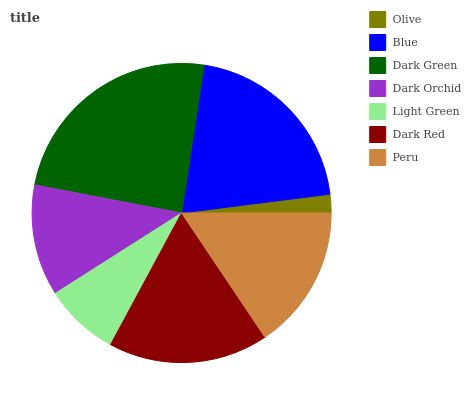Is Olive the minimum?
Answer yes or no. Yes. Is Dark Green the maximum?
Answer yes or no. Yes. Is Blue the minimum?
Answer yes or no. No. Is Blue the maximum?
Answer yes or no. No. Is Blue greater than Olive?
Answer yes or no. Yes. Is Olive less than Blue?
Answer yes or no. Yes. Is Olive greater than Blue?
Answer yes or no. No. Is Blue less than Olive?
Answer yes or no. No. Is Peru the high median?
Answer yes or no. Yes. Is Peru the low median?
Answer yes or no. Yes. Is Dark Green the high median?
Answer yes or no. No. Is Light Green the low median?
Answer yes or no. No. 